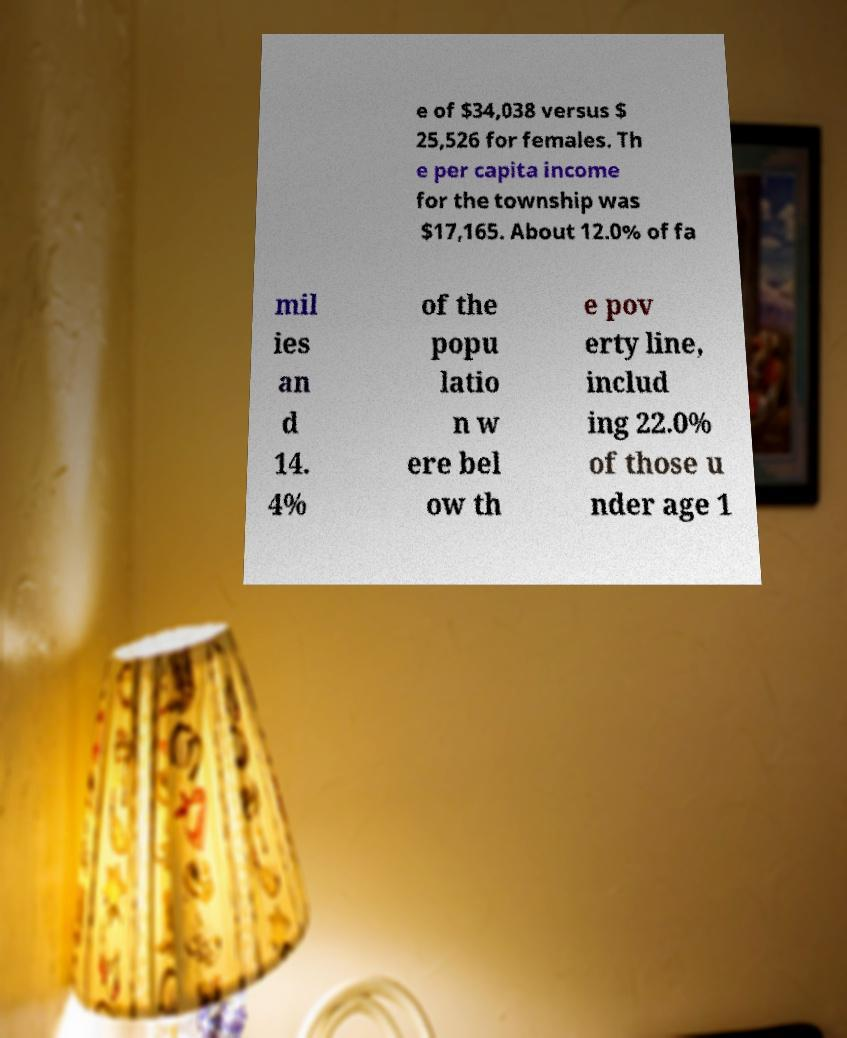Can you accurately transcribe the text from the provided image for me? e of $34,038 versus $ 25,526 for females. Th e per capita income for the township was $17,165. About 12.0% of fa mil ies an d 14. 4% of the popu latio n w ere bel ow th e pov erty line, includ ing 22.0% of those u nder age 1 